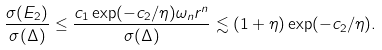<formula> <loc_0><loc_0><loc_500><loc_500>\frac { \sigma ( E _ { 2 } ) } { \sigma ( \Delta ) } \leq \frac { c _ { 1 } \exp ( - c _ { 2 } / \eta ) \omega _ { n } r ^ { n } } { \sigma ( \Delta ) } \lesssim ( 1 + \eta ) \exp ( - c _ { 2 } / \eta ) .</formula> 